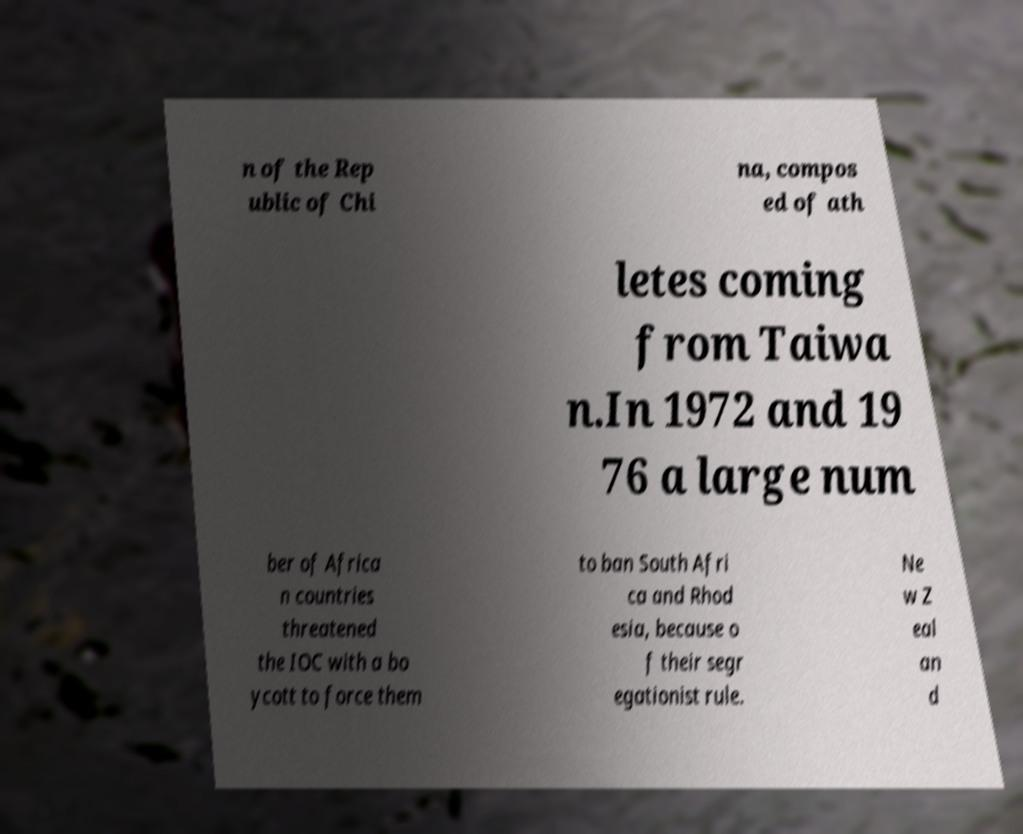Could you assist in decoding the text presented in this image and type it out clearly? n of the Rep ublic of Chi na, compos ed of ath letes coming from Taiwa n.In 1972 and 19 76 a large num ber of Africa n countries threatened the IOC with a bo ycott to force them to ban South Afri ca and Rhod esia, because o f their segr egationist rule. Ne w Z eal an d 